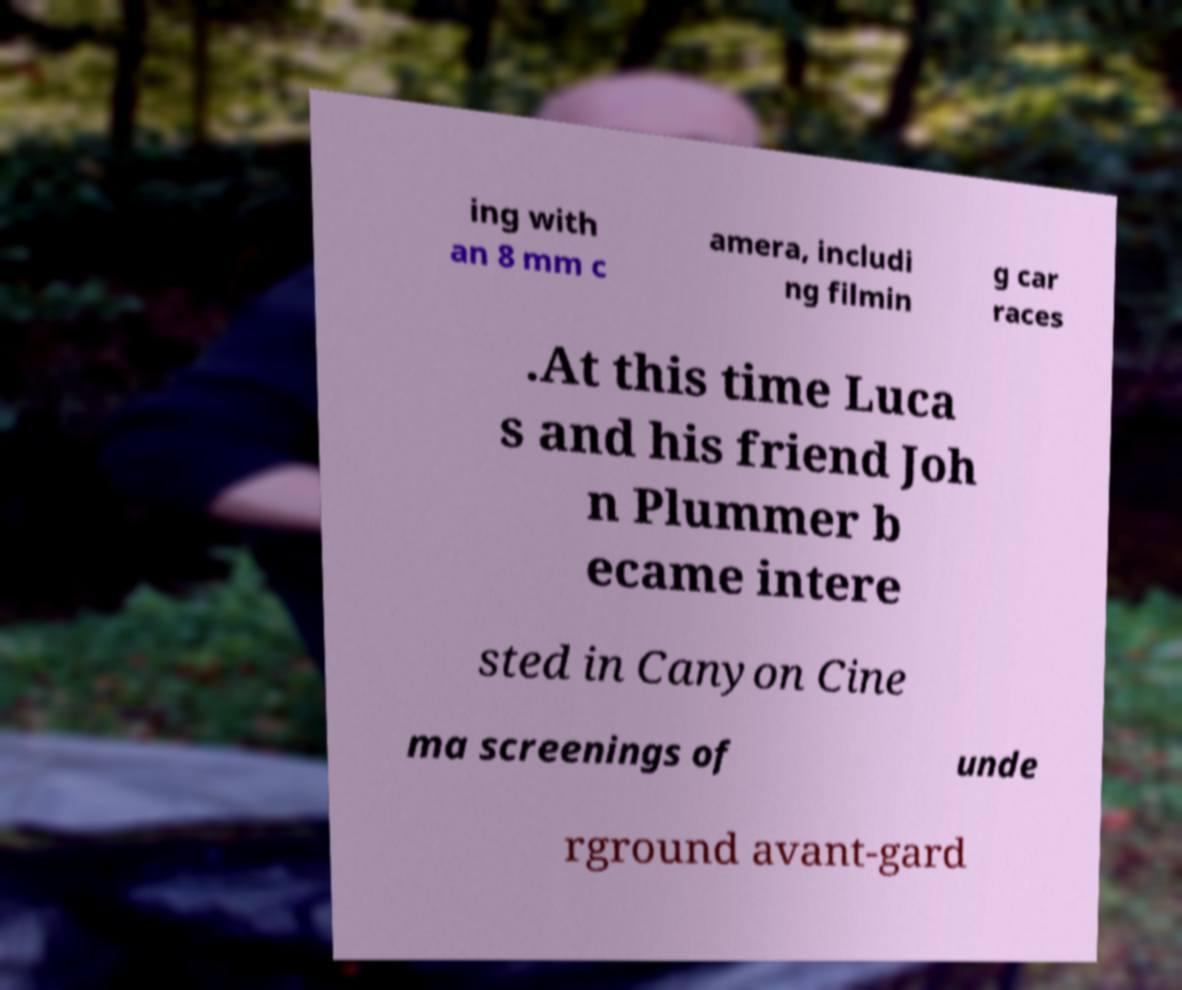Please read and relay the text visible in this image. What does it say? ing with an 8 mm c amera, includi ng filmin g car races .At this time Luca s and his friend Joh n Plummer b ecame intere sted in Canyon Cine ma screenings of unde rground avant-gard 